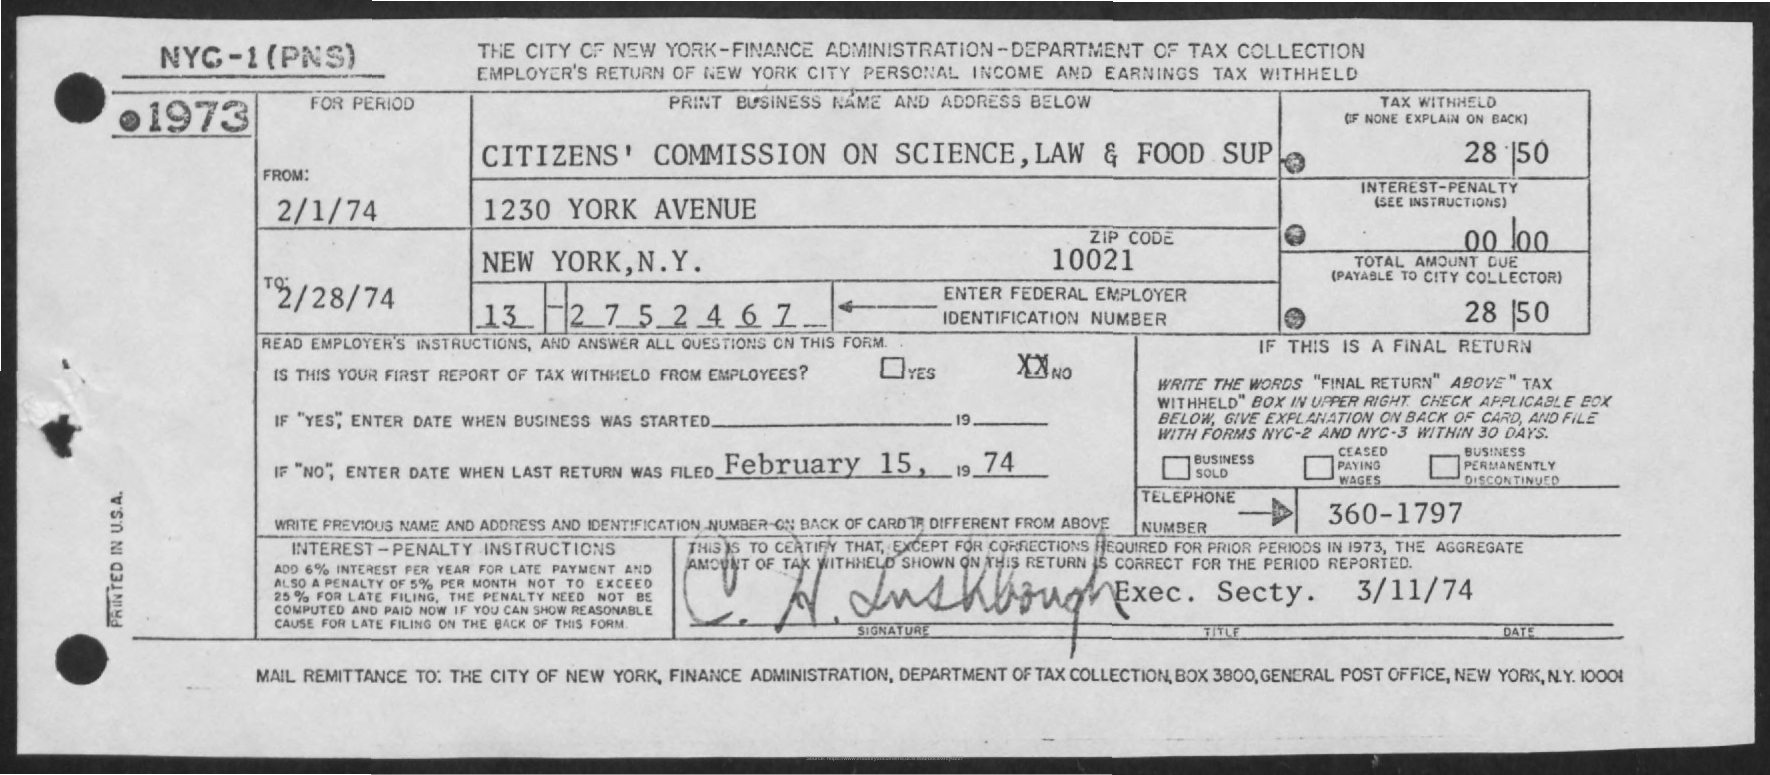How much is the Tax Withheld?
Your answer should be very brief. 28 50. What is the Interest-Penalty?
Offer a very short reply. 00.00. What is the "From" Period?
Your answer should be very brief. 2/1/74. What is the "To" Period?
Keep it short and to the point. 2/28/74. What is the Zip Code?
Ensure brevity in your answer.  10021. What is the Total Amount Due?
Provide a succinct answer. 28 50. When was last return filed?
Make the answer very short. February 15, 1974. What is the Telephone Number?
Your answer should be very brief. 360-1797. 